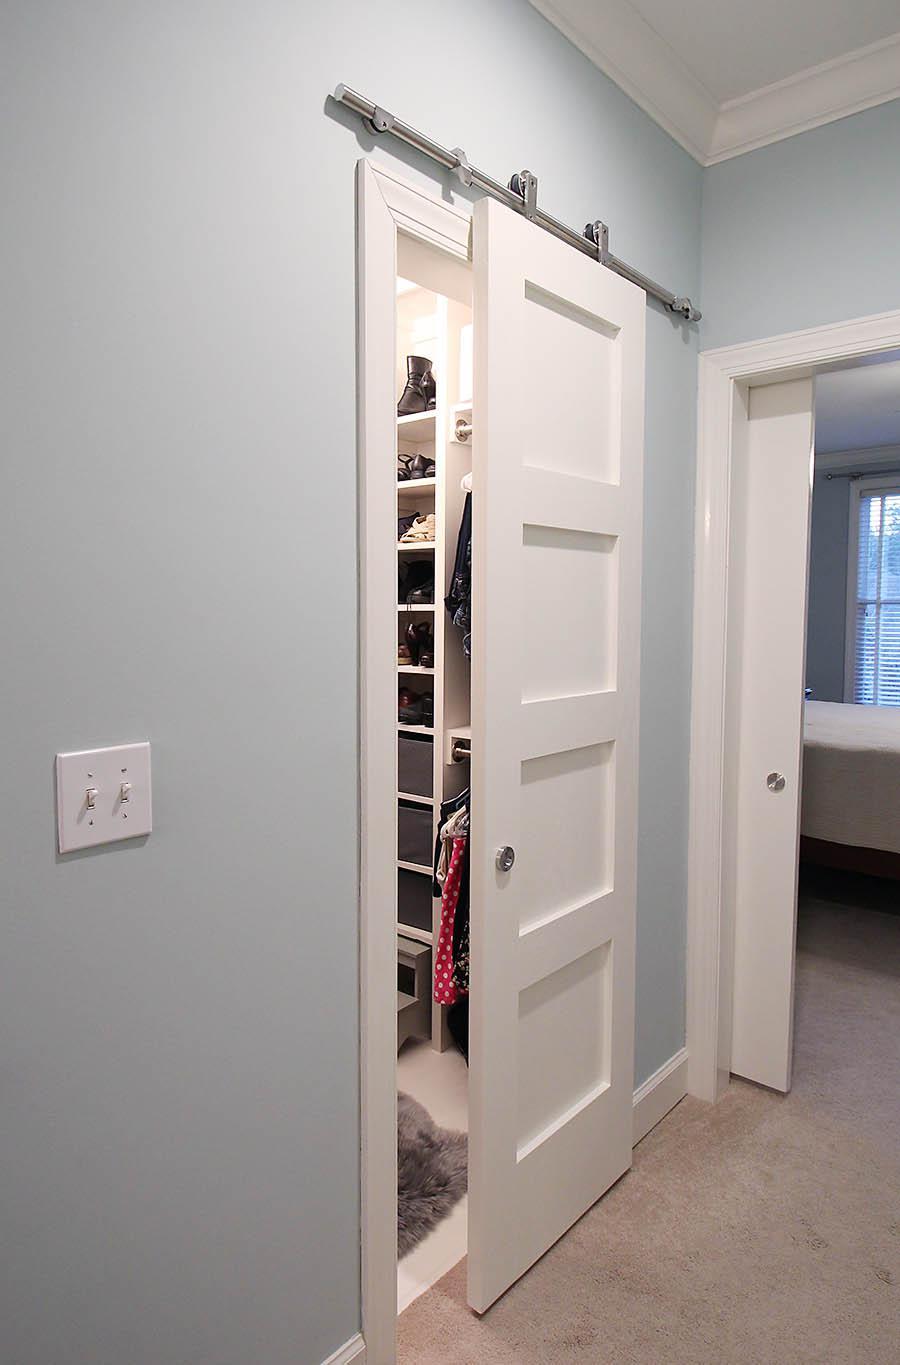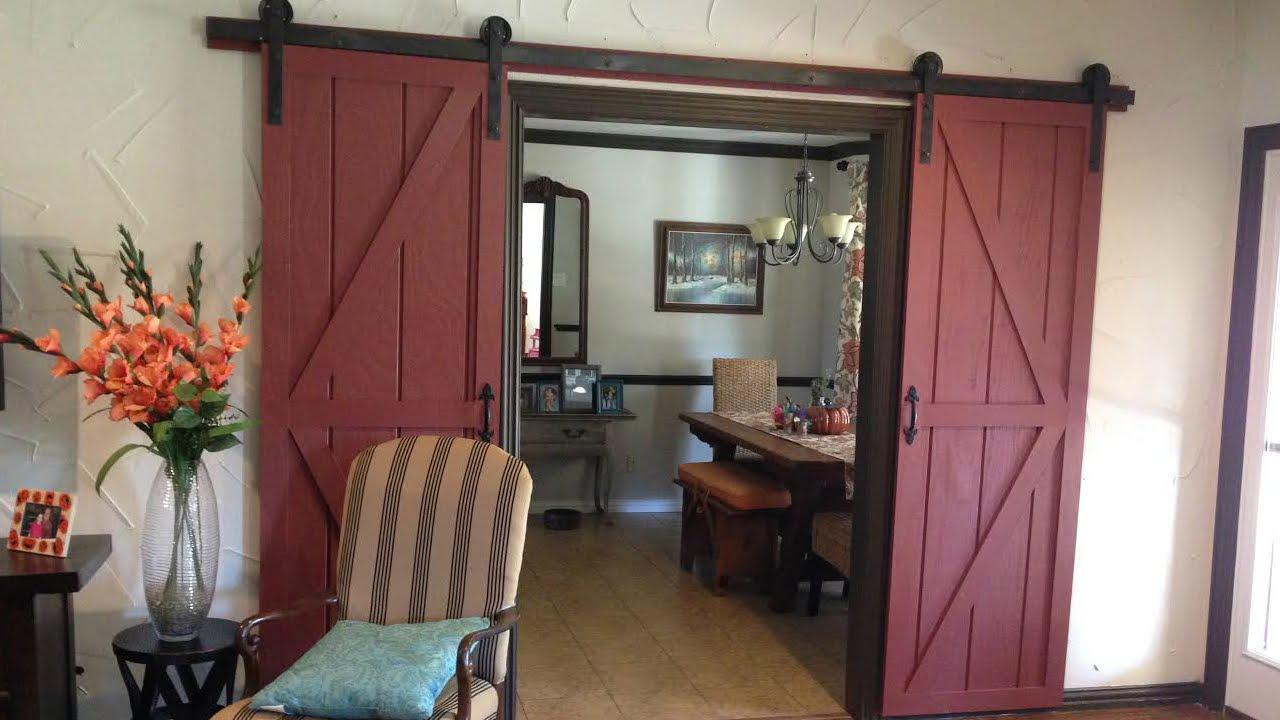The first image is the image on the left, the second image is the image on the right. For the images displayed, is the sentence "One image shows a two-paneled barn door with angled wood trim and no windows." factually correct? Answer yes or no. Yes. 